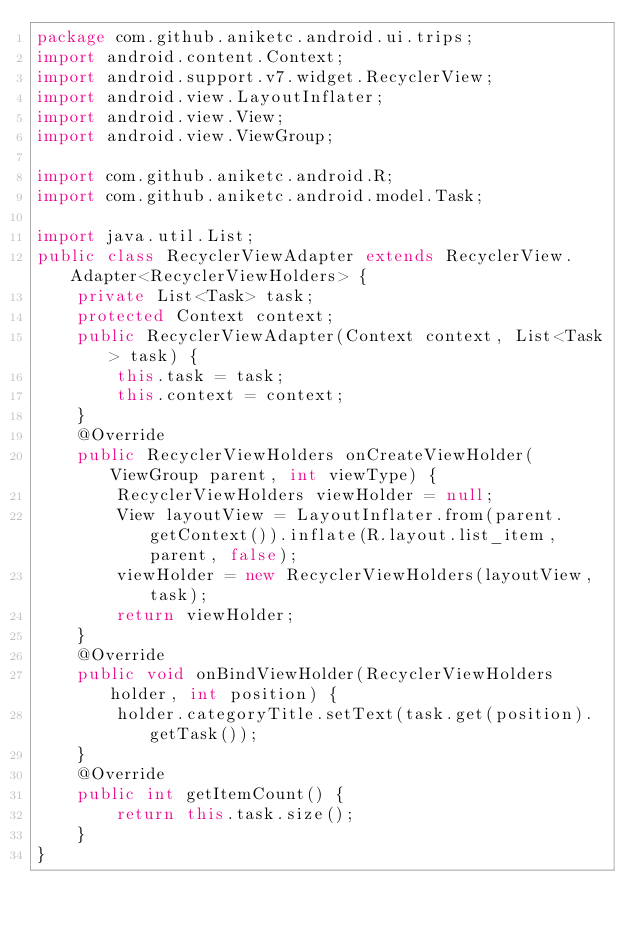Convert code to text. <code><loc_0><loc_0><loc_500><loc_500><_Java_>package com.github.aniketc.android.ui.trips;
import android.content.Context;
import android.support.v7.widget.RecyclerView;
import android.view.LayoutInflater;
import android.view.View;
import android.view.ViewGroup;

import com.github.aniketc.android.R;
import com.github.aniketc.android.model.Task;

import java.util.List;
public class RecyclerViewAdapter extends RecyclerView.Adapter<RecyclerViewHolders> {
    private List<Task> task;
    protected Context context;
    public RecyclerViewAdapter(Context context, List<Task> task) {
        this.task = task;
        this.context = context;
    }
    @Override
    public RecyclerViewHolders onCreateViewHolder(ViewGroup parent, int viewType) {
        RecyclerViewHolders viewHolder = null;
        View layoutView = LayoutInflater.from(parent.getContext()).inflate(R.layout.list_item, parent, false);
        viewHolder = new RecyclerViewHolders(layoutView, task);
        return viewHolder;
    }
    @Override
    public void onBindViewHolder(RecyclerViewHolders holder, int position) {
        holder.categoryTitle.setText(task.get(position).getTask());
    }
    @Override
    public int getItemCount() {
        return this.task.size();
    }
}</code> 